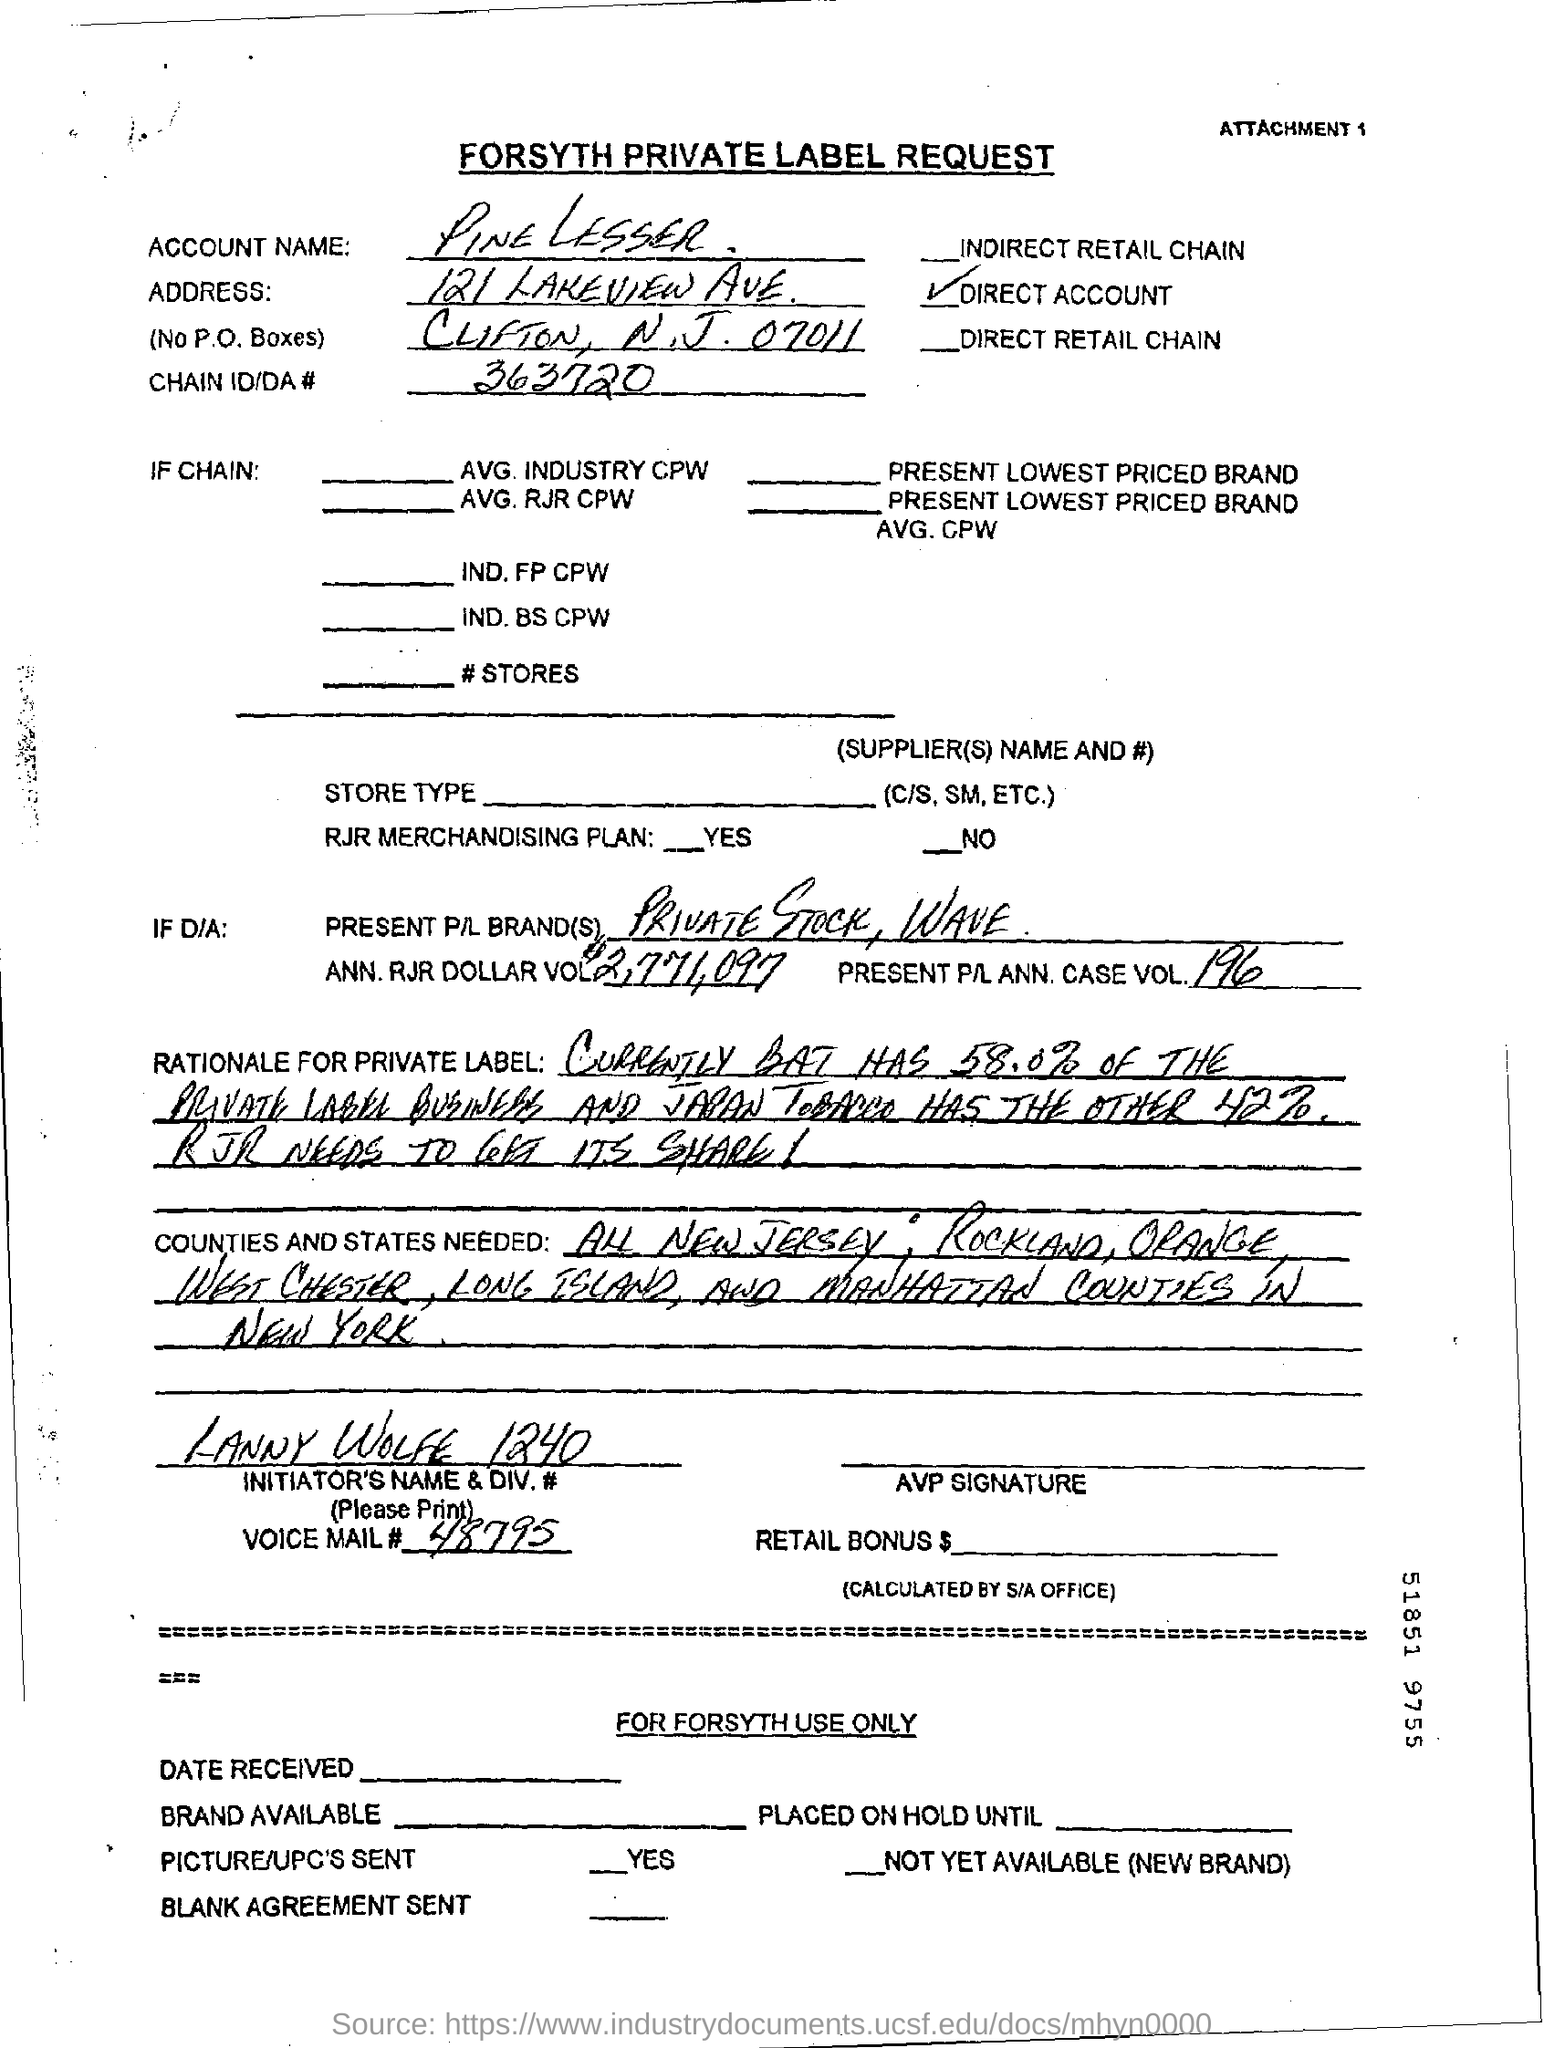What is the account name given in the form?
Provide a succinct answer. Pine Lesser. What is the chain ID/DA no given in the form?
Your answer should be compact. 363720. What is the voice mail no mentioned in the form?
Give a very brief answer. 48795. 